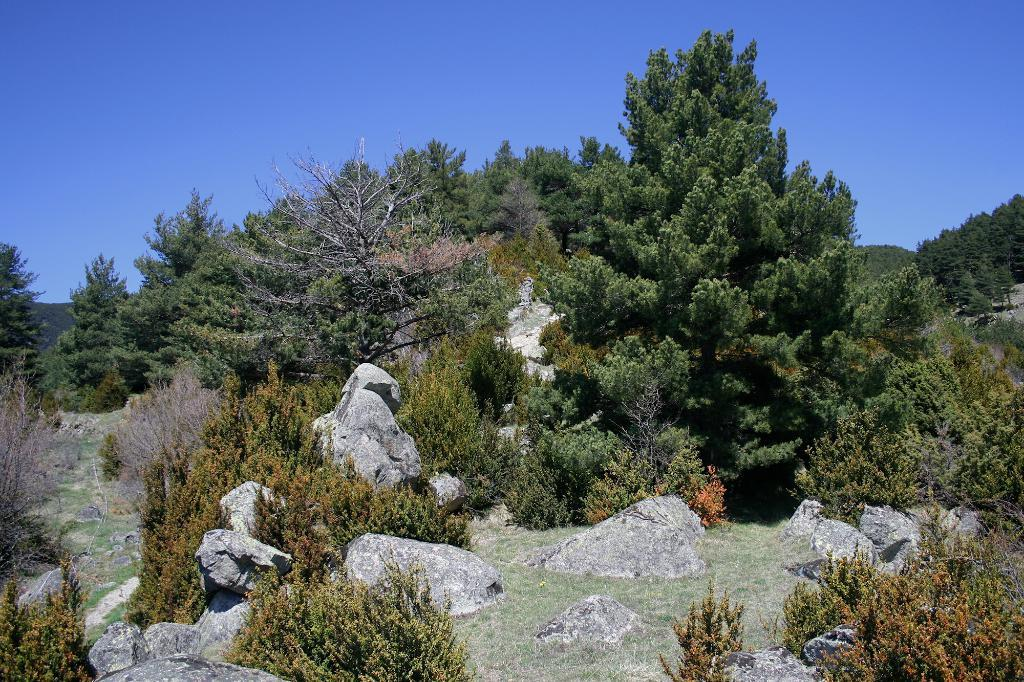What type of natural elements can be seen in the image? There are rocks, plants, trees, and grass on the ground in the image. What is visible in the background of the image? There are mountains in the background of the image. What is visible at the top of the image? The sky is visible at the top of the image. What type of pets can be seen playing with the rocks in the image? There are no pets visible in the image; it features rocks, plants, trees, grass, mountains, and the sky. What joke is being told by the trees in the image? There is no joke being told by the trees in the image; they are simply trees in a natural setting. 